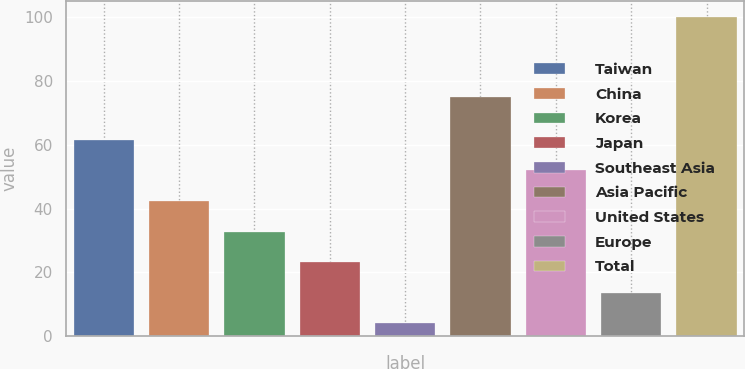<chart> <loc_0><loc_0><loc_500><loc_500><bar_chart><fcel>Taiwan<fcel>China<fcel>Korea<fcel>Japan<fcel>Southeast Asia<fcel>Asia Pacific<fcel>United States<fcel>Europe<fcel>Total<nl><fcel>61.6<fcel>42.4<fcel>32.8<fcel>23.2<fcel>4<fcel>75<fcel>52<fcel>13.6<fcel>100<nl></chart> 